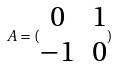Convert formula to latex. <formula><loc_0><loc_0><loc_500><loc_500>A = ( \begin{matrix} 0 & 1 \\ - 1 & 0 \end{matrix} )</formula> 